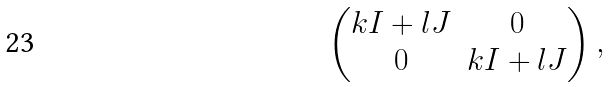<formula> <loc_0><loc_0><loc_500><loc_500>\begin{pmatrix} k I + l J & 0 \\ 0 & k I + l J \end{pmatrix} ,</formula> 